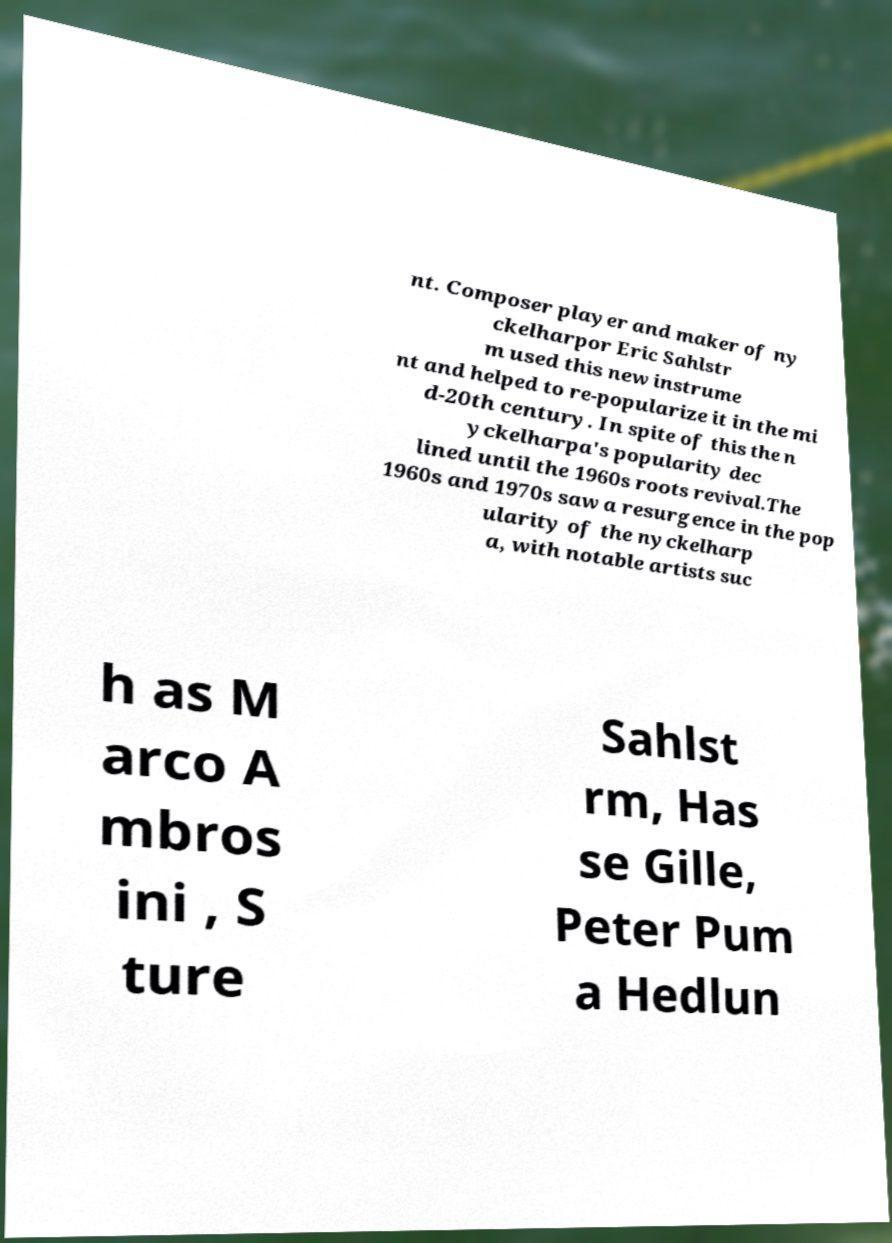Can you accurately transcribe the text from the provided image for me? nt. Composer player and maker of ny ckelharpor Eric Sahlstr m used this new instrume nt and helped to re-popularize it in the mi d-20th century. In spite of this the n yckelharpa's popularity dec lined until the 1960s roots revival.The 1960s and 1970s saw a resurgence in the pop ularity of the nyckelharp a, with notable artists suc h as M arco A mbros ini , S ture Sahlst rm, Has se Gille, Peter Pum a Hedlun 